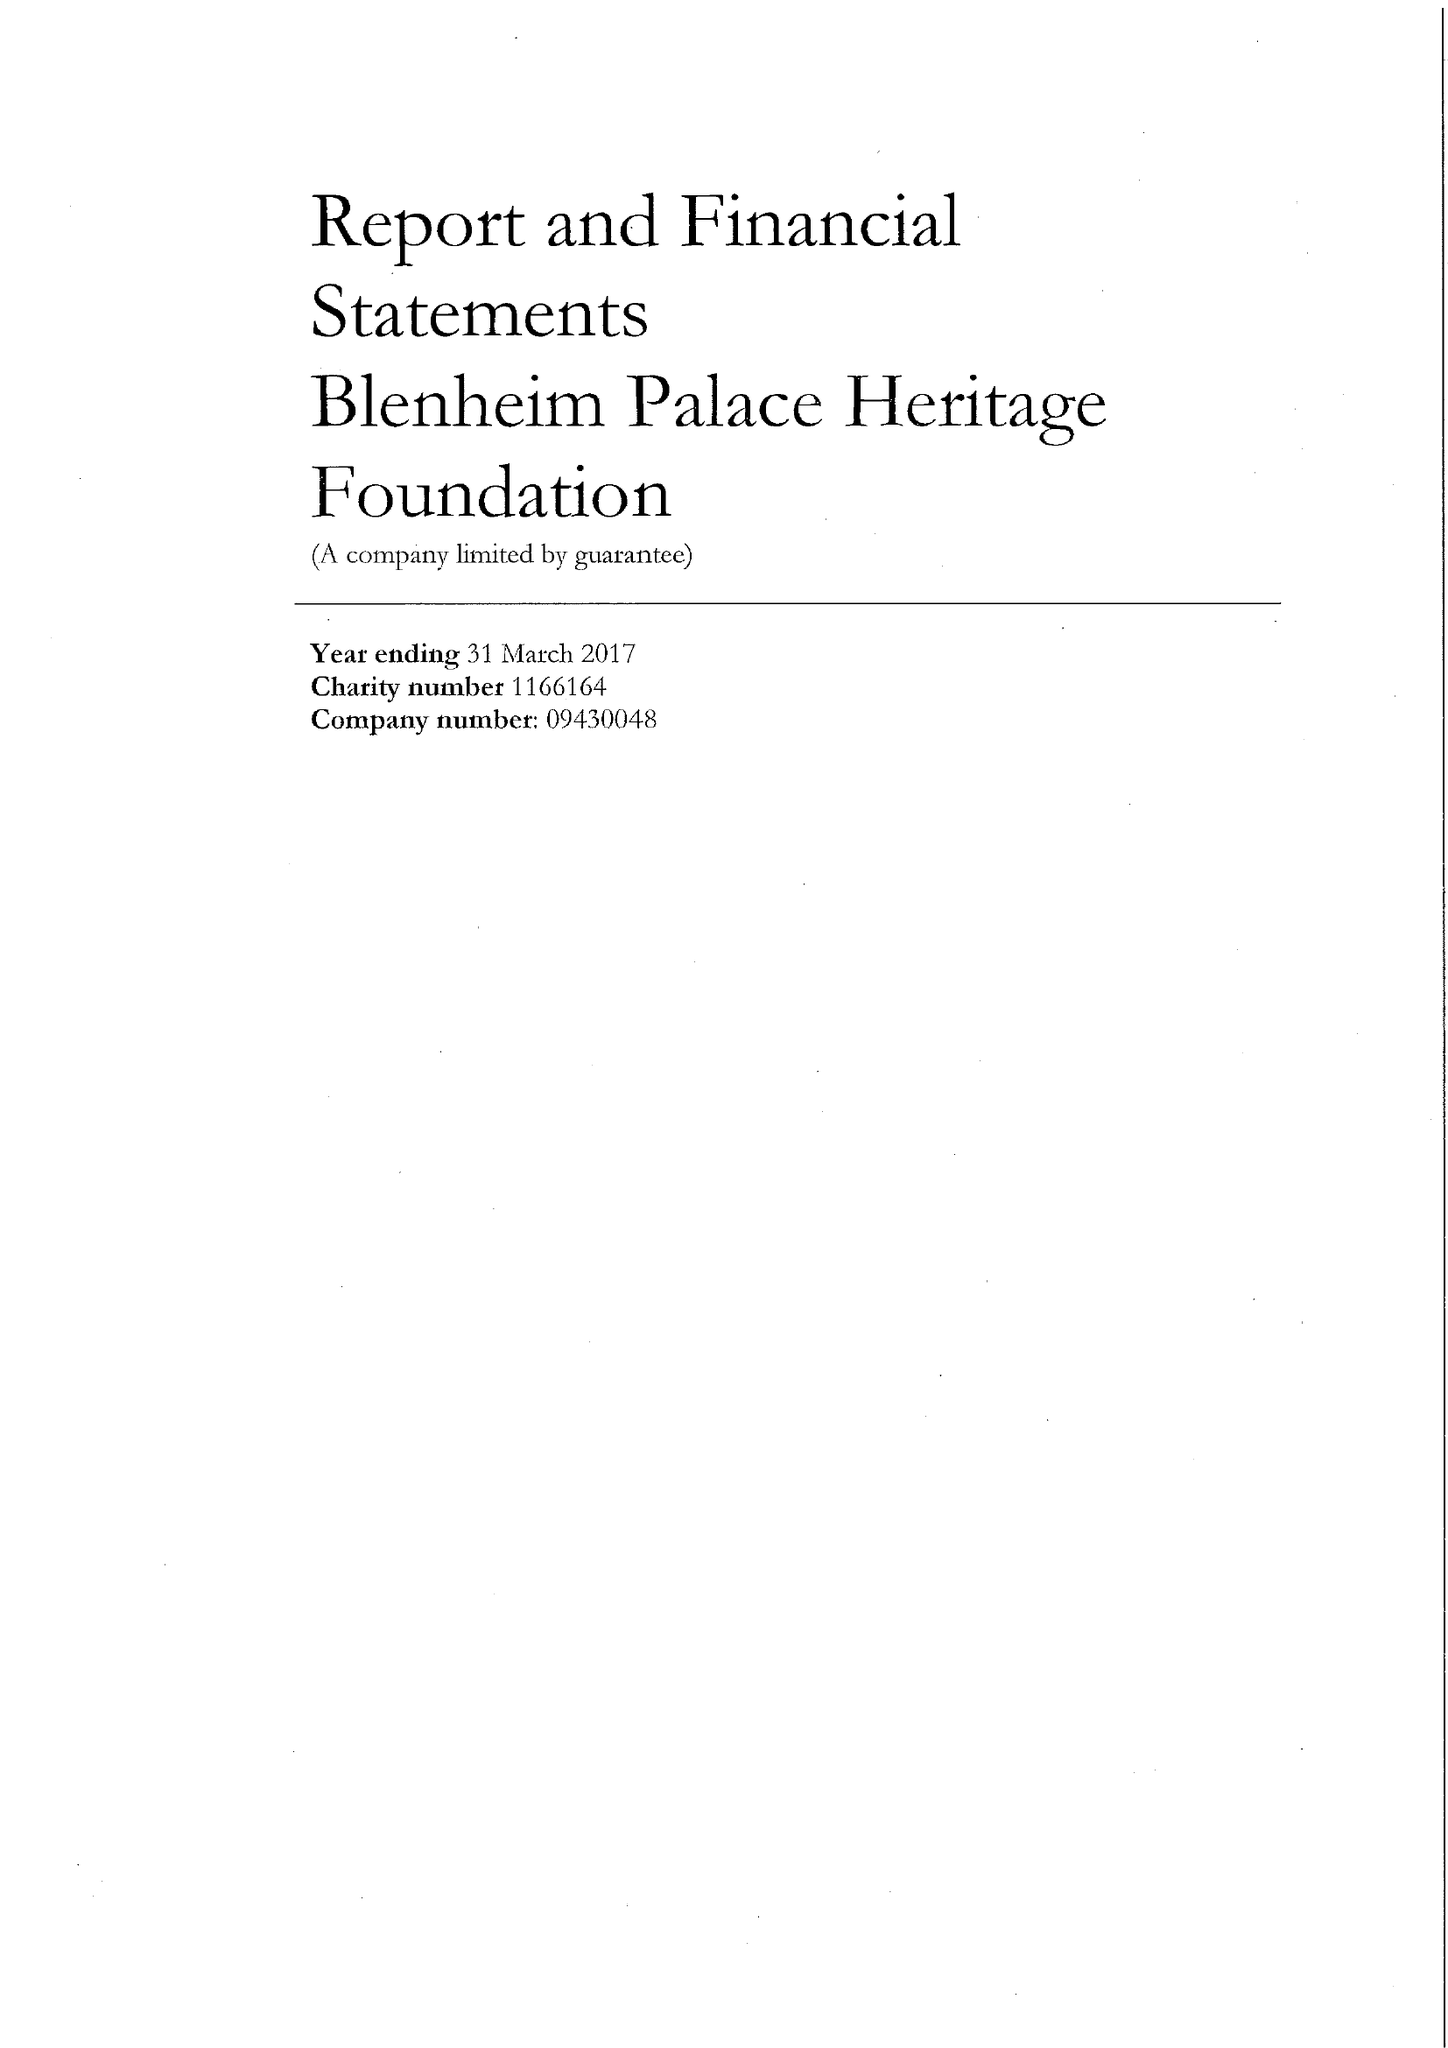What is the value for the spending_annually_in_british_pounds?
Answer the question using a single word or phrase. 4136373.00 